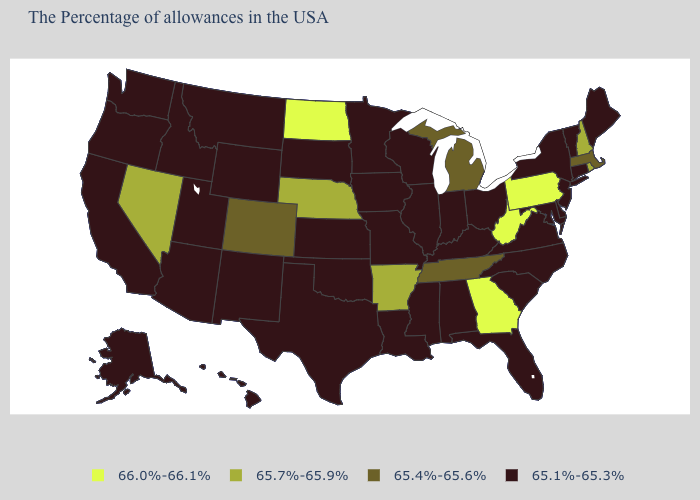What is the value of Arkansas?
Answer briefly. 65.7%-65.9%. Which states have the lowest value in the MidWest?
Short answer required. Ohio, Indiana, Wisconsin, Illinois, Missouri, Minnesota, Iowa, Kansas, South Dakota. What is the value of Rhode Island?
Short answer required. 65.7%-65.9%. Does Nevada have the lowest value in the West?
Concise answer only. No. What is the value of Utah?
Keep it brief. 65.1%-65.3%. Does Nevada have the highest value in the West?
Write a very short answer. Yes. Which states have the lowest value in the USA?
Concise answer only. Maine, Vermont, Connecticut, New York, New Jersey, Delaware, Maryland, Virginia, North Carolina, South Carolina, Ohio, Florida, Kentucky, Indiana, Alabama, Wisconsin, Illinois, Mississippi, Louisiana, Missouri, Minnesota, Iowa, Kansas, Oklahoma, Texas, South Dakota, Wyoming, New Mexico, Utah, Montana, Arizona, Idaho, California, Washington, Oregon, Alaska, Hawaii. Which states hav the highest value in the South?
Be succinct. West Virginia, Georgia. Name the states that have a value in the range 65.7%-65.9%?
Be succinct. Rhode Island, New Hampshire, Arkansas, Nebraska, Nevada. What is the highest value in the Northeast ?
Write a very short answer. 66.0%-66.1%. What is the value of Oregon?
Be succinct. 65.1%-65.3%. Which states have the highest value in the USA?
Quick response, please. Pennsylvania, West Virginia, Georgia, North Dakota. Among the states that border North Carolina , which have the lowest value?
Write a very short answer. Virginia, South Carolina. Among the states that border Georgia , which have the lowest value?
Answer briefly. North Carolina, South Carolina, Florida, Alabama. 